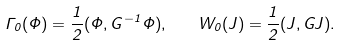<formula> <loc_0><loc_0><loc_500><loc_500>\Gamma _ { 0 } ( \Phi ) = \frac { 1 } { 2 } ( \Phi , G ^ { - 1 } \Phi ) , \quad W _ { 0 } ( J ) = \frac { 1 } { 2 } ( J , G J ) .</formula> 